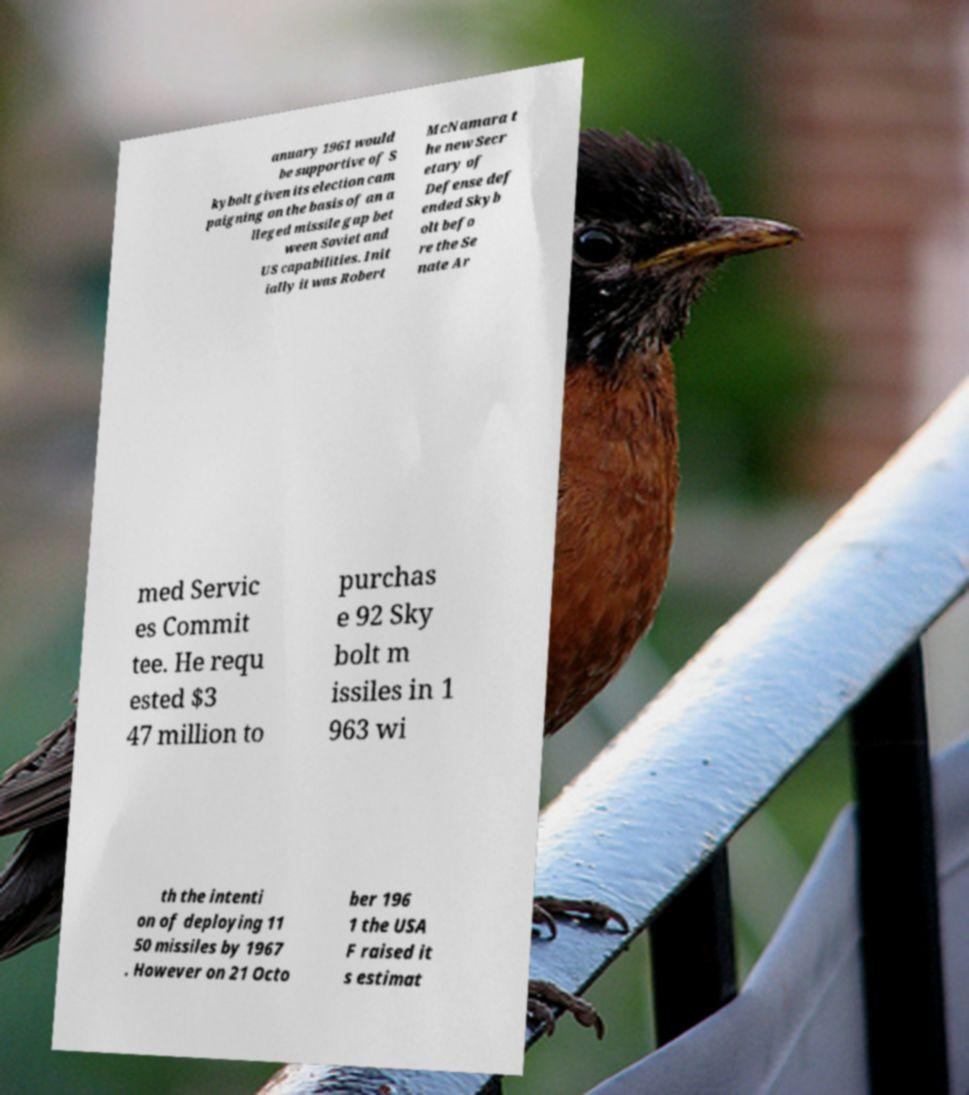Can you read and provide the text displayed in the image?This photo seems to have some interesting text. Can you extract and type it out for me? anuary 1961 would be supportive of S kybolt given its election cam paigning on the basis of an a lleged missile gap bet ween Soviet and US capabilities. Init ially it was Robert McNamara t he new Secr etary of Defense def ended Skyb olt befo re the Se nate Ar med Servic es Commit tee. He requ ested $3 47 million to purchas e 92 Sky bolt m issiles in 1 963 wi th the intenti on of deploying 11 50 missiles by 1967 . However on 21 Octo ber 196 1 the USA F raised it s estimat 